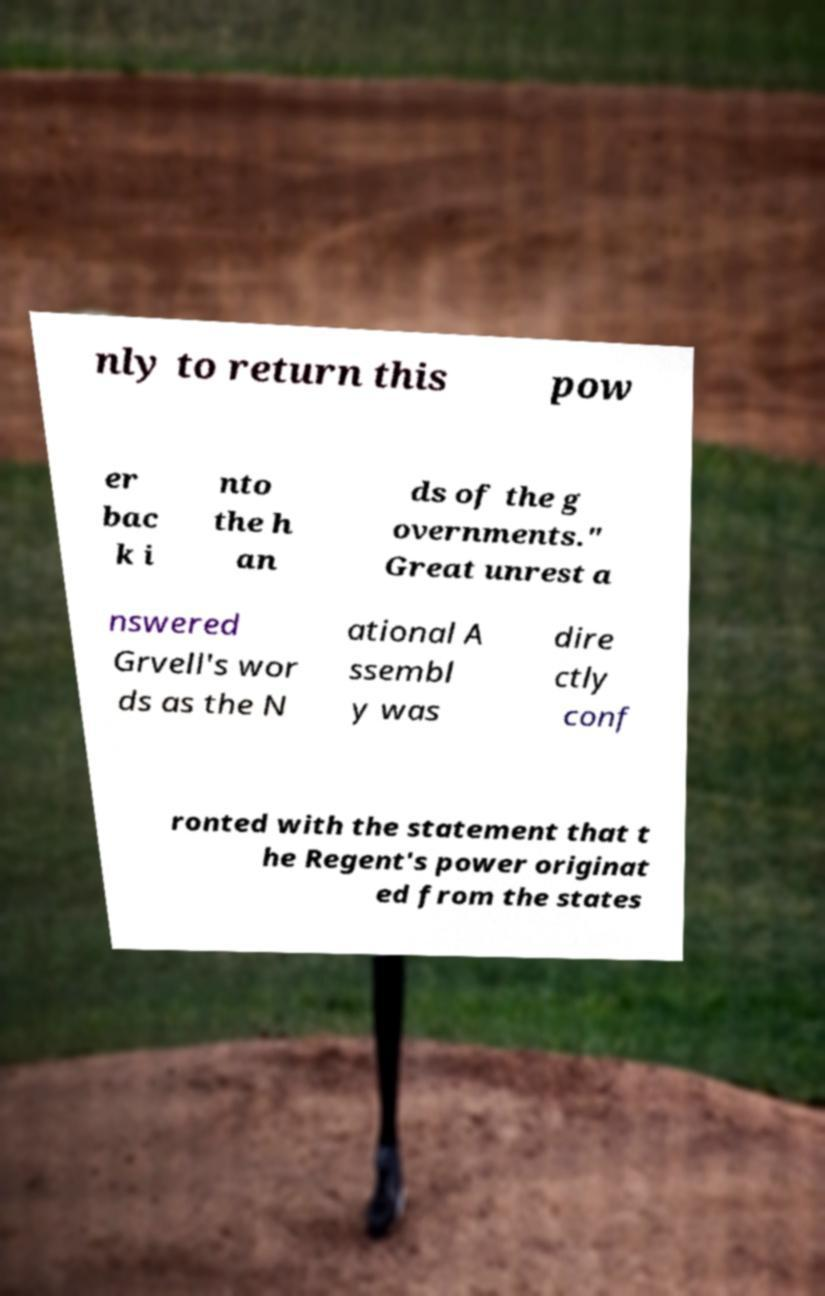I need the written content from this picture converted into text. Can you do that? nly to return this pow er bac k i nto the h an ds of the g overnments." Great unrest a nswered Grvell's wor ds as the N ational A ssembl y was dire ctly conf ronted with the statement that t he Regent's power originat ed from the states 